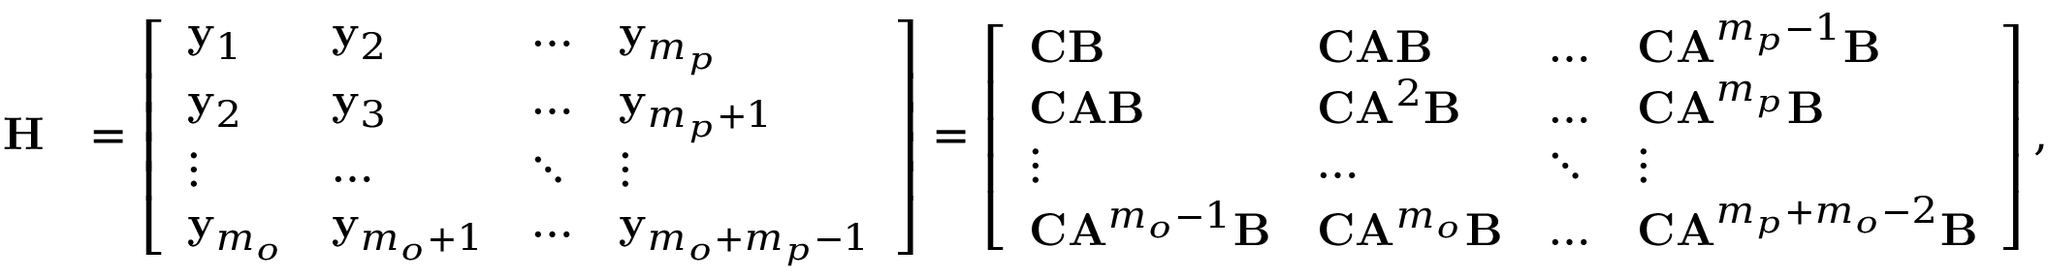Convert formula to latex. <formula><loc_0><loc_0><loc_500><loc_500>\begin{array} { r l } { H } & { = \left [ \begin{array} { l l l l } { y _ { 1 } } & { y _ { 2 } } & { \dots } & { y _ { m _ { p } } } \\ { y _ { 2 } } & { y _ { 3 } } & { \dots } & { y _ { m _ { p } + 1 } } \\ { \vdots } & { \dots } & { \ddots } & { \vdots } \\ { y _ { m _ { o } } } & { y _ { m _ { o } + 1 } } & { \dots } & { y _ { m _ { o } + m _ { p } - 1 } } \end{array} \right ] = \left [ \begin{array} { l l l l } { C B } & { C A B } & { \dots } & { C A ^ { m _ { p } - 1 } B } \\ { C A B } & { C A ^ { 2 } B } & { \dots } & { C A ^ { m _ { p } } B } \\ { \vdots } & { \dots } & { \ddots } & { \vdots } \\ { C A ^ { m _ { o } - 1 } B } & { C A ^ { m _ { o } } B } & { \dots } & { C A ^ { m _ { p } + m _ { o } - 2 } B } \end{array} \right ] , } \end{array}</formula> 